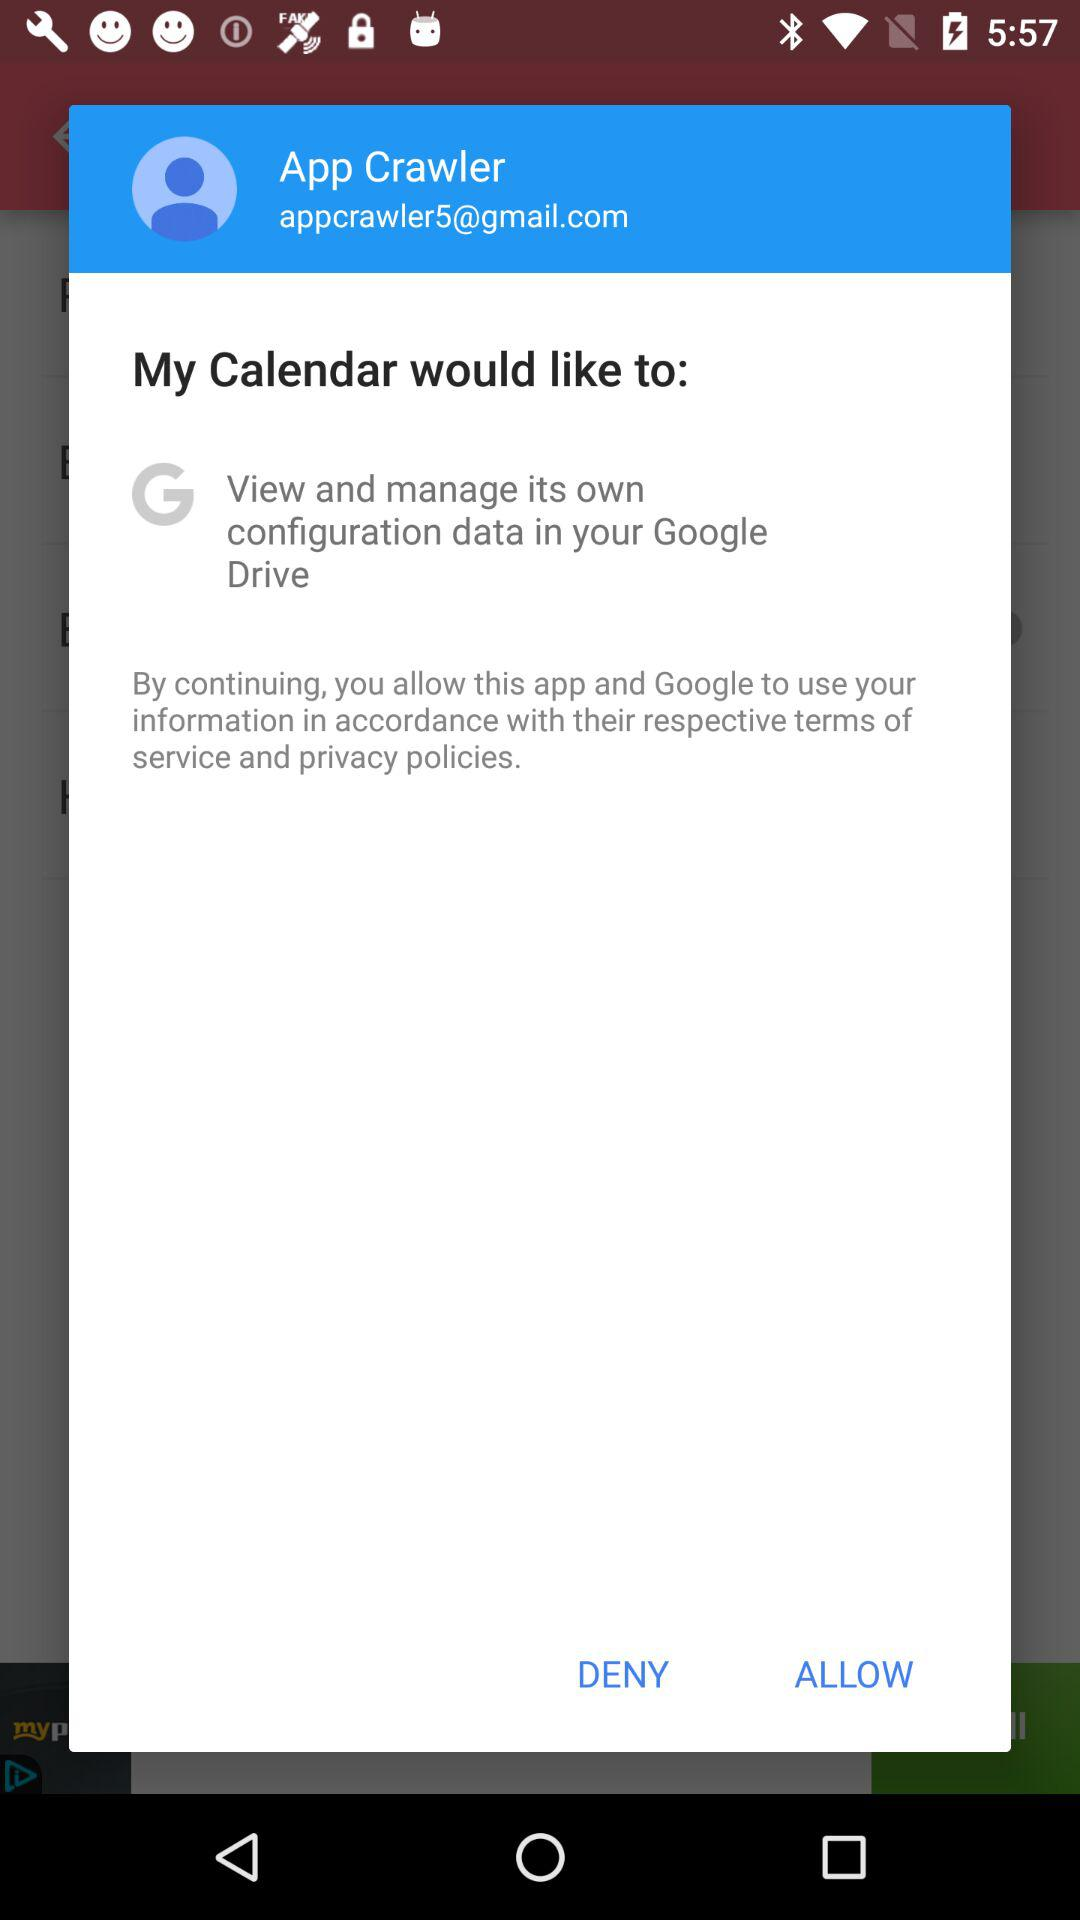What's the user profile name? The user profile name is "App Crawler". 